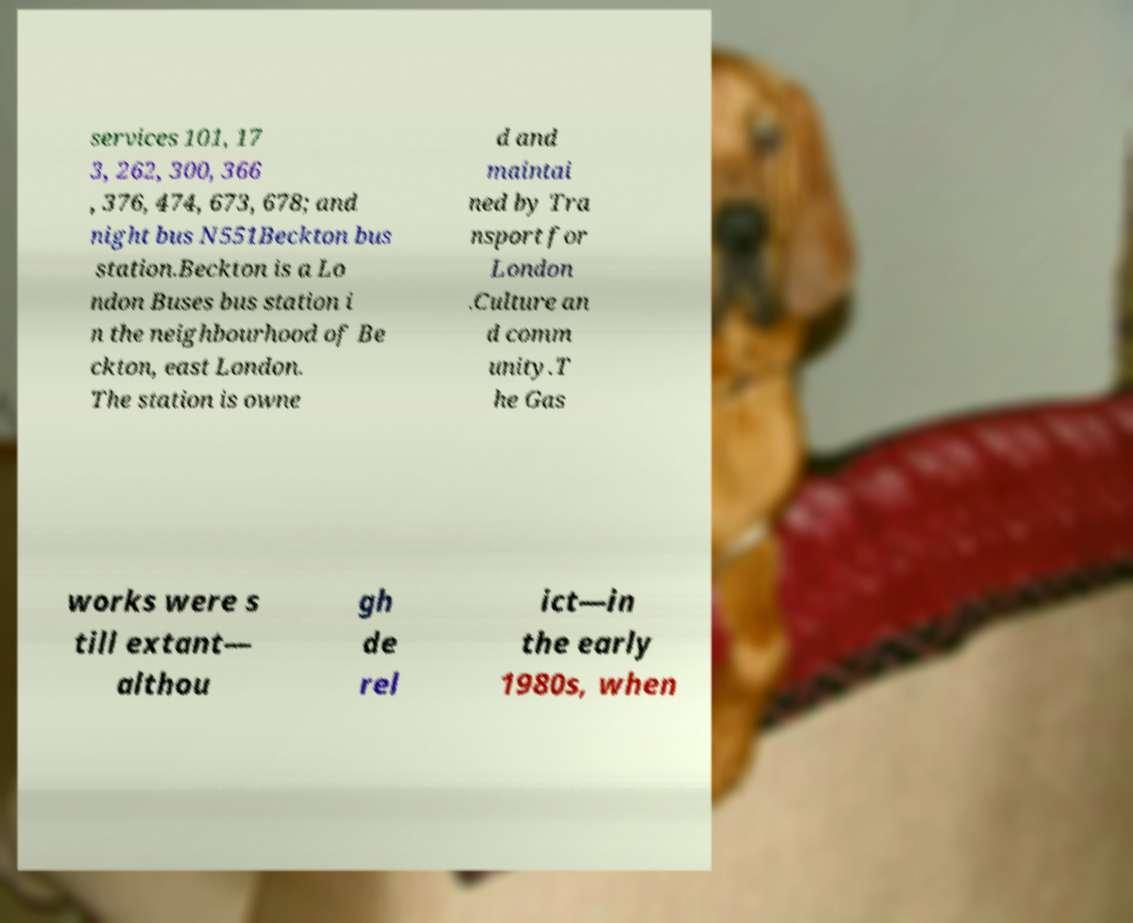Could you extract and type out the text from this image? services 101, 17 3, 262, 300, 366 , 376, 474, 673, 678; and night bus N551Beckton bus station.Beckton is a Lo ndon Buses bus station i n the neighbourhood of Be ckton, east London. The station is owne d and maintai ned by Tra nsport for London .Culture an d comm unity.T he Gas works were s till extant— althou gh de rel ict—in the early 1980s, when 